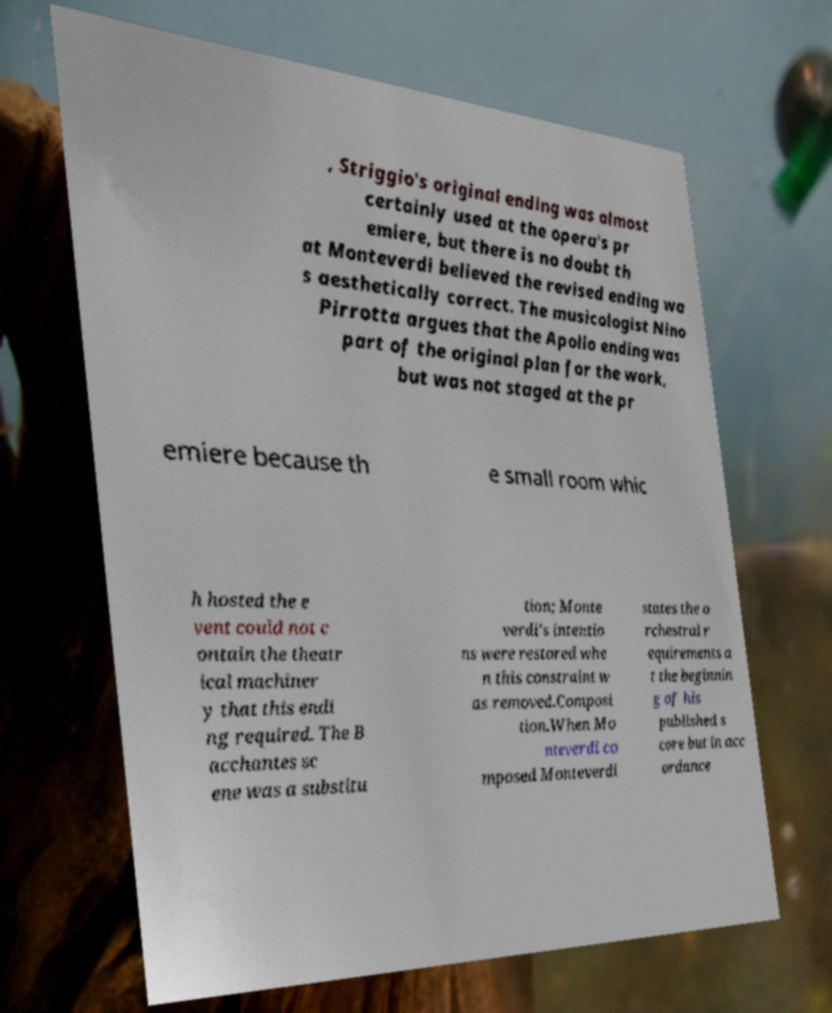For documentation purposes, I need the text within this image transcribed. Could you provide that? , Striggio's original ending was almost certainly used at the opera's pr emiere, but there is no doubt th at Monteverdi believed the revised ending wa s aesthetically correct. The musicologist Nino Pirrotta argues that the Apollo ending was part of the original plan for the work, but was not staged at the pr emiere because th e small room whic h hosted the e vent could not c ontain the theatr ical machiner y that this endi ng required. The B acchantes sc ene was a substitu tion; Monte verdi's intentio ns were restored whe n this constraint w as removed.Composi tion.When Mo nteverdi co mposed Monteverdi states the o rchestral r equirements a t the beginnin g of his published s core but in acc ordance 